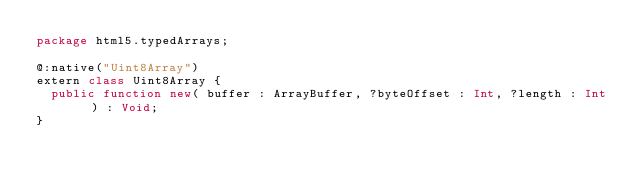<code> <loc_0><loc_0><loc_500><loc_500><_Haxe_>package html5.typedArrays;

@:native("Uint8Array")
extern class Uint8Array {
	public function new( buffer : ArrayBuffer, ?byteOffset : Int, ?length : Int ) : Void;	
}</code> 